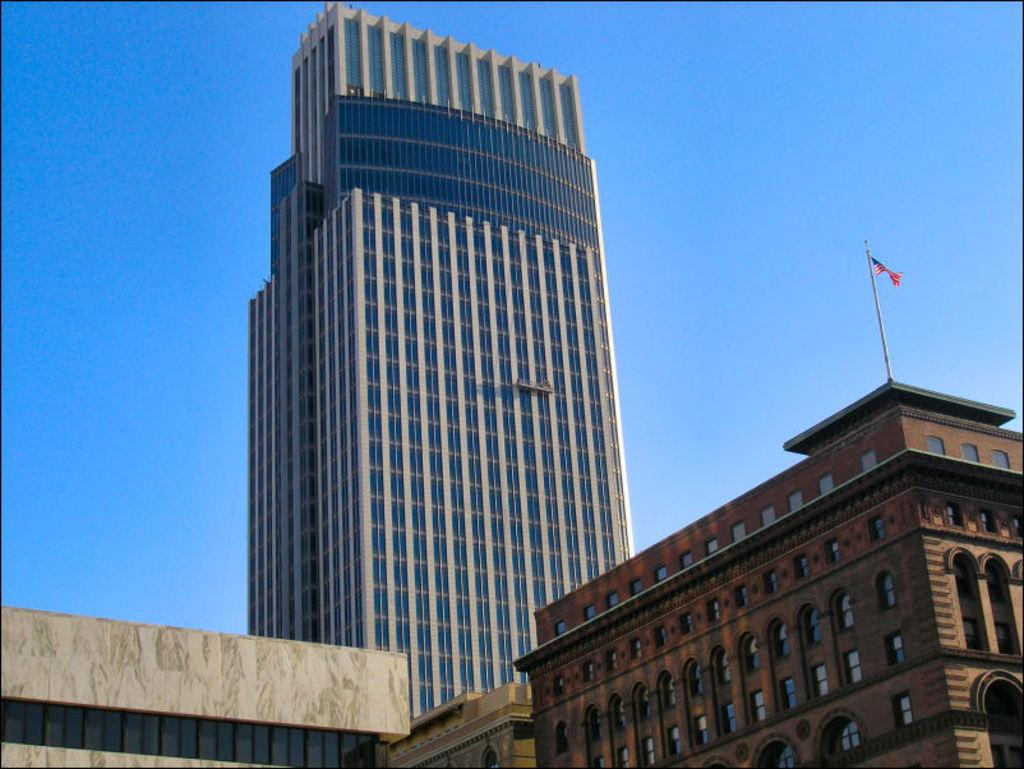What is a part of the natural environment that can be seen in the image? The sky is a part of the natural environment that can be seen in the image. What type of man-made structures are present in the image? There are buildings in the image. What feature is common to many of the buildings in the image? Windows are present in the image. What symbol or emblem can be seen in the image? There is a flag in the image. What architectural element is present in the image? There is a wall in the image. What type of punishment is being administered to the buildings in the image? There is no punishment being administered to the buildings in the image; they are simply standing. What type of experience can be gained by interacting with the flag in the image? There is no interaction with the flag in the image, so no experience can be gained from it. 